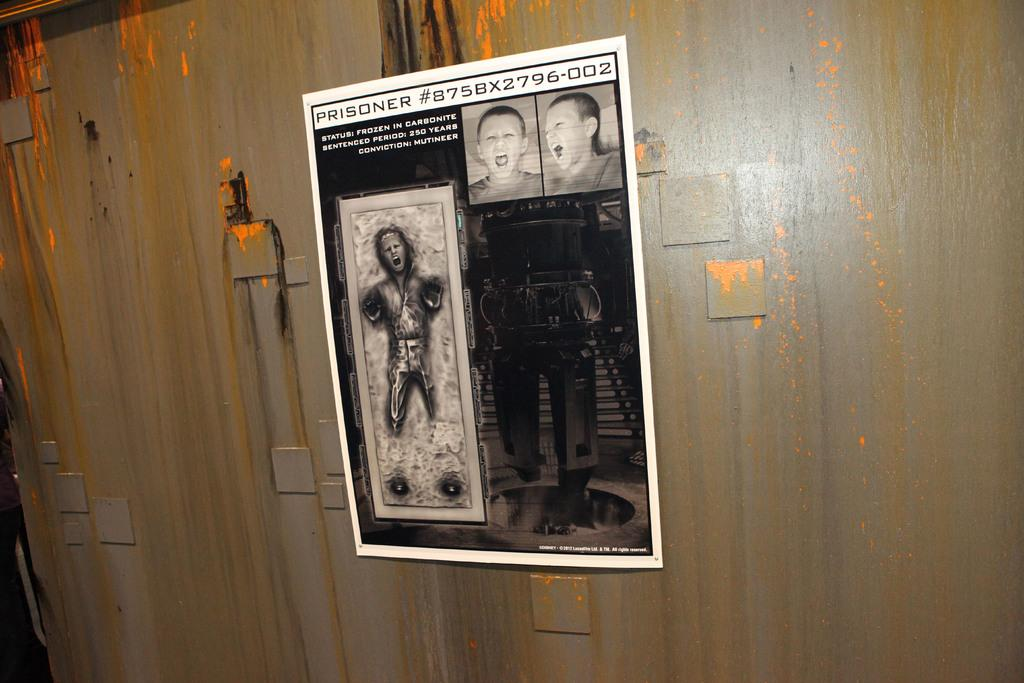<image>
Give a short and clear explanation of the subsequent image. a mold of a prisoner on a piece of paper 